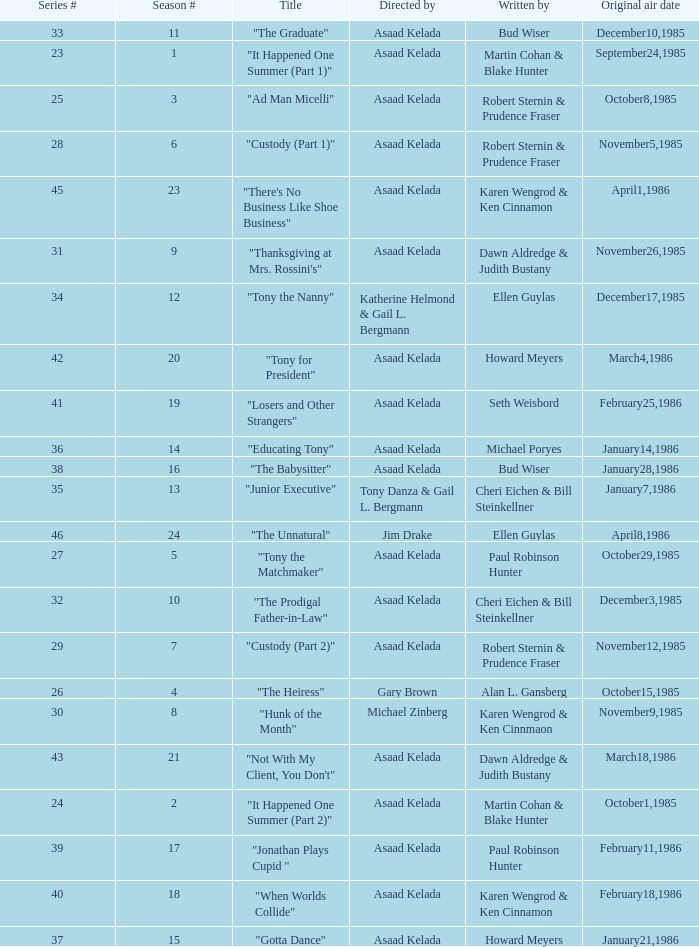Who were the authors of series episode #25? Robert Sternin & Prudence Fraser. 